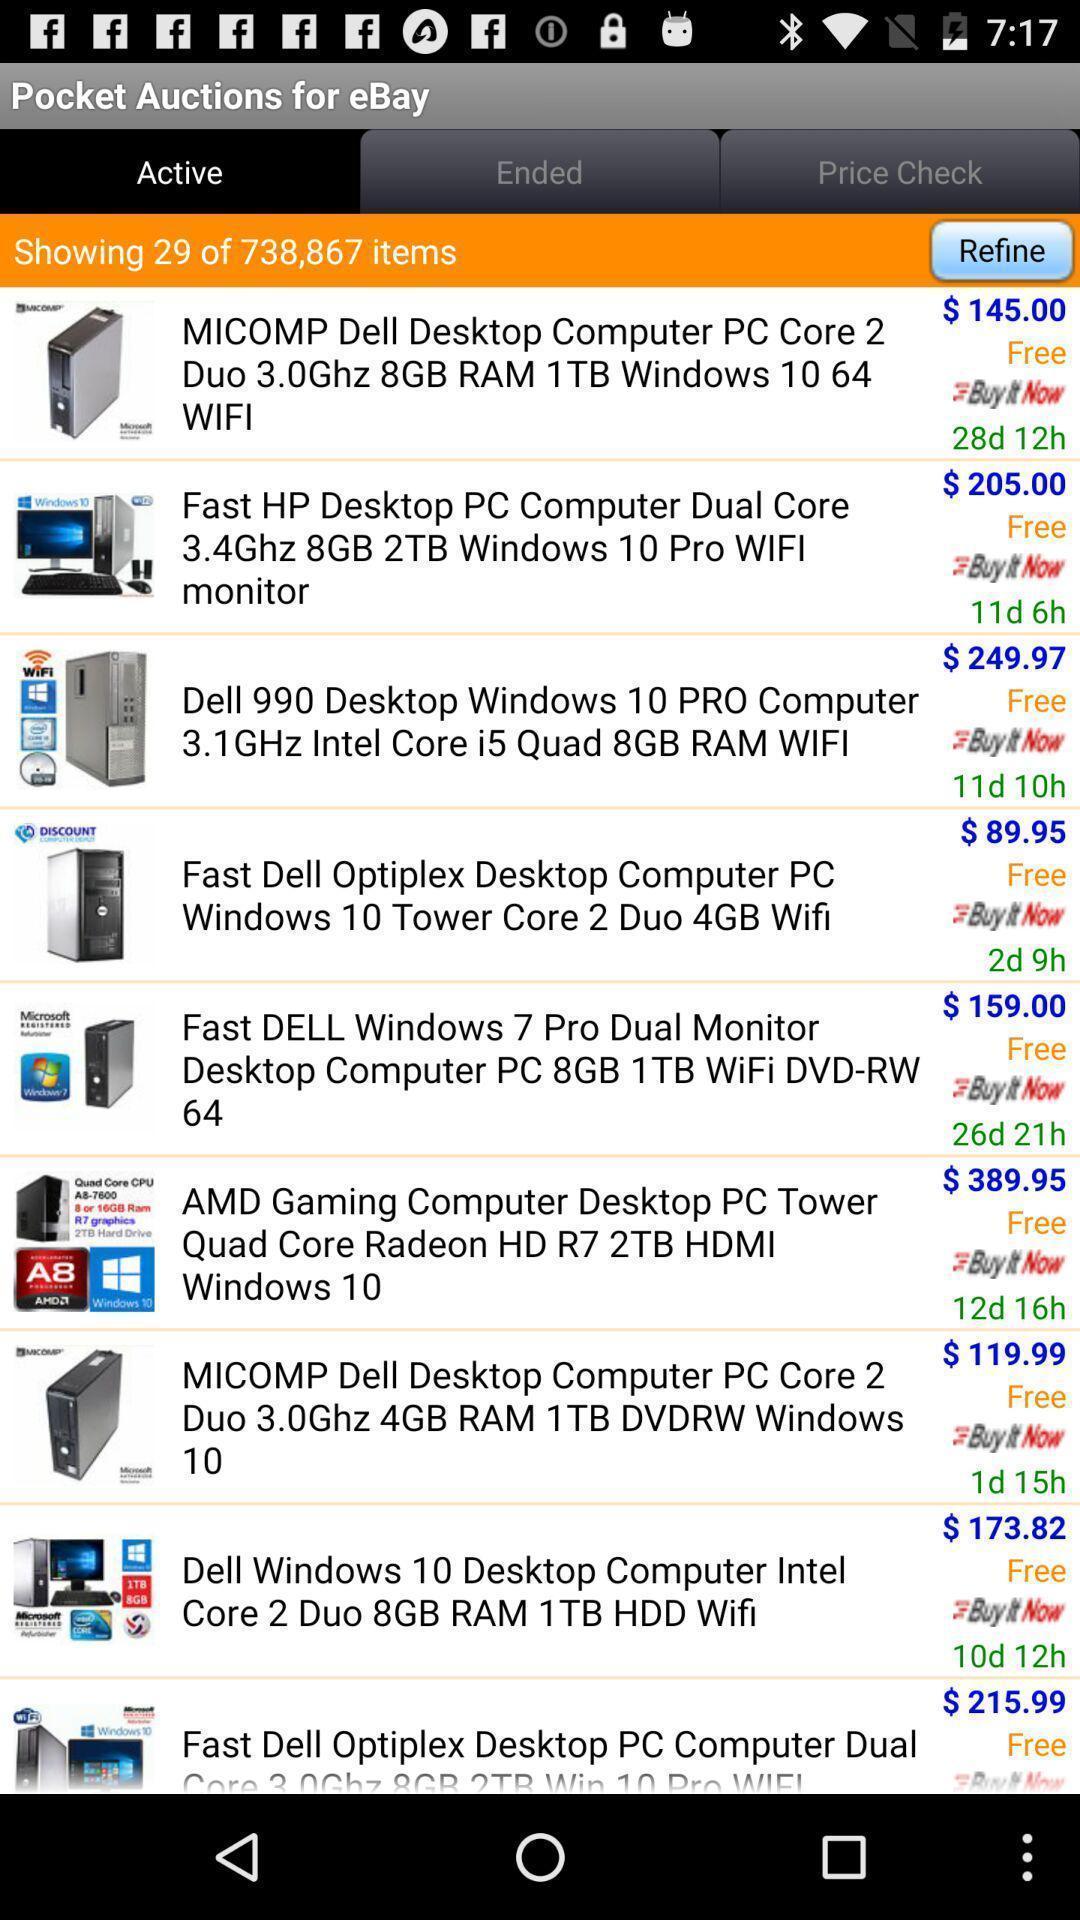Summarize the main components in this picture. Screen shows list of products in a shopping application. 